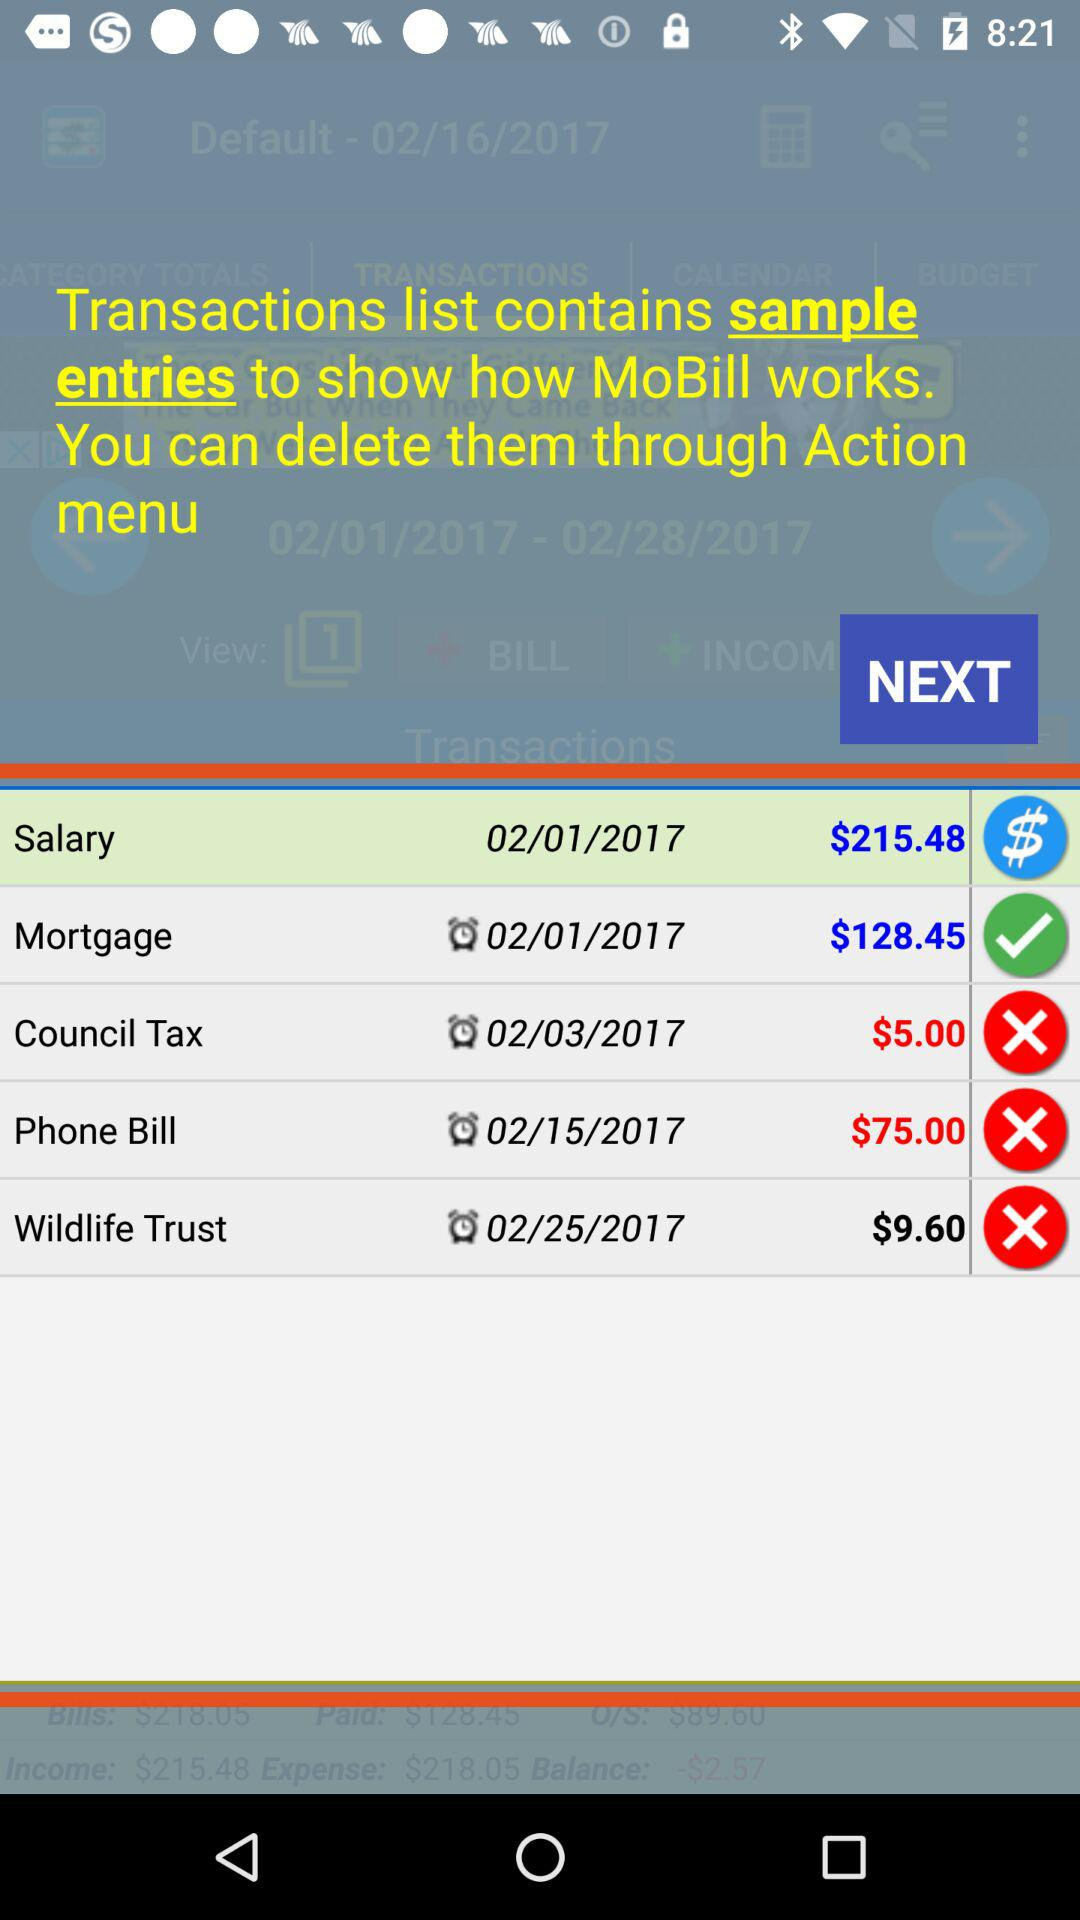Which option is checked? The checked option is "Mortgage". 